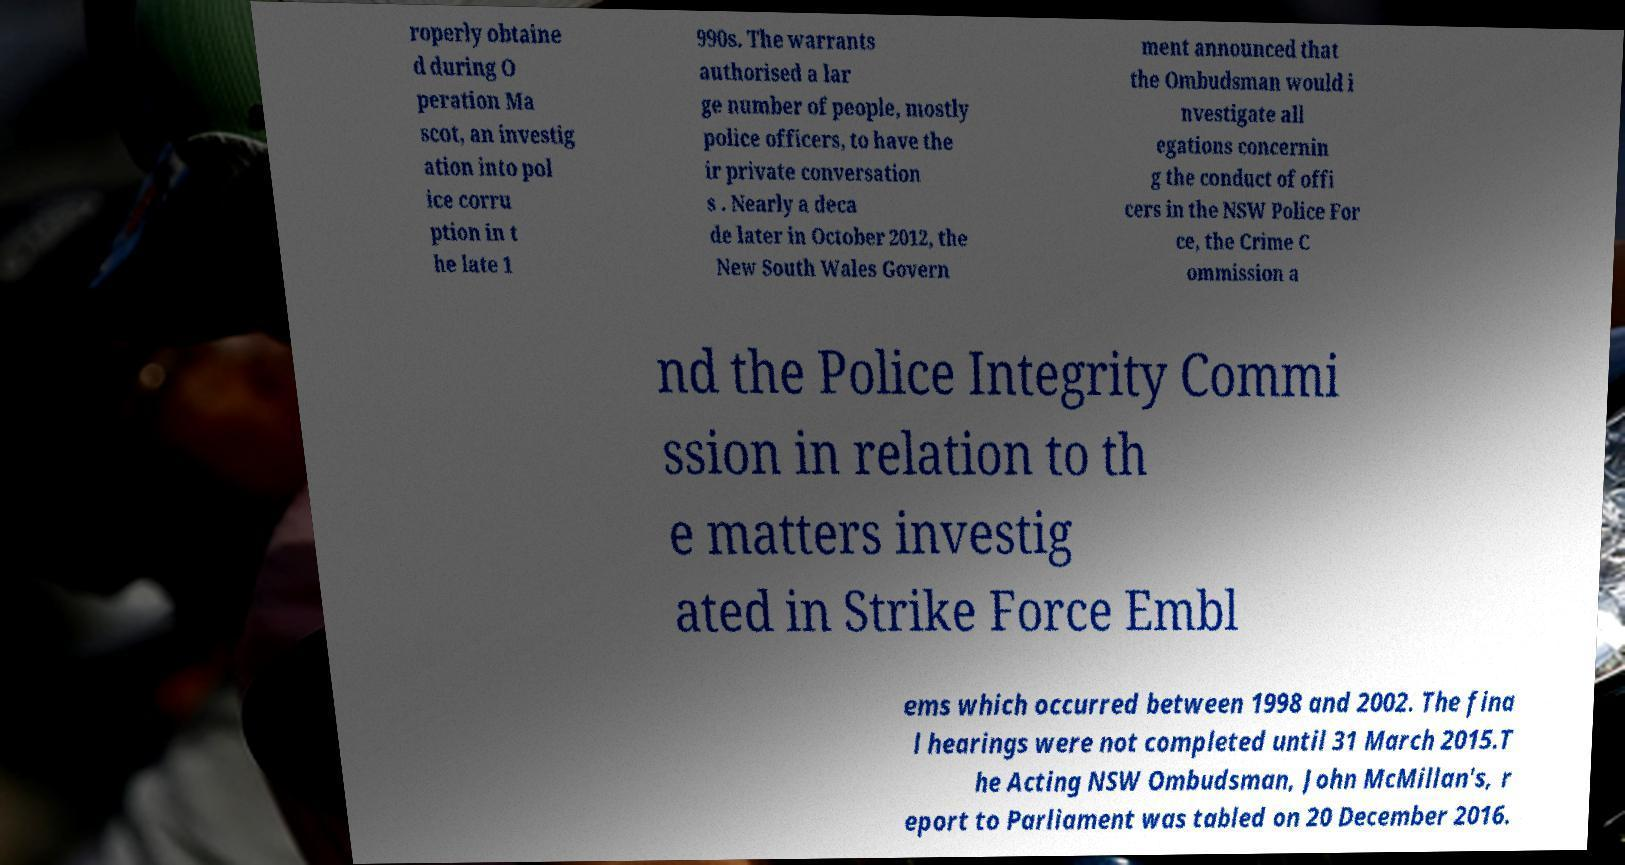Could you assist in decoding the text presented in this image and type it out clearly? roperly obtaine d during O peration Ma scot, an investig ation into pol ice corru ption in t he late 1 990s. The warrants authorised a lar ge number of people, mostly police officers, to have the ir private conversation s . Nearly a deca de later in October 2012, the New South Wales Govern ment announced that the Ombudsman would i nvestigate all egations concernin g the conduct of offi cers in the NSW Police For ce, the Crime C ommission a nd the Police Integrity Commi ssion in relation to th e matters investig ated in Strike Force Embl ems which occurred between 1998 and 2002. The fina l hearings were not completed until 31 March 2015.T he Acting NSW Ombudsman, John McMillan's, r eport to Parliament was tabled on 20 December 2016. 